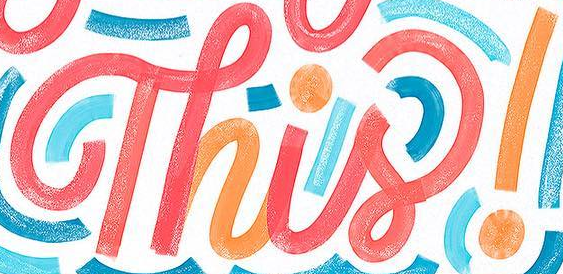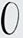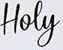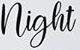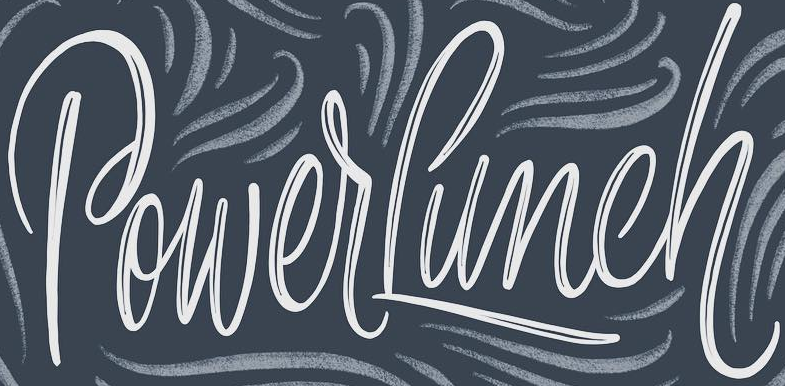What text is displayed in these images sequentially, separated by a semicolon? Thisǃ; O; Hoey; night; PowerLunch 